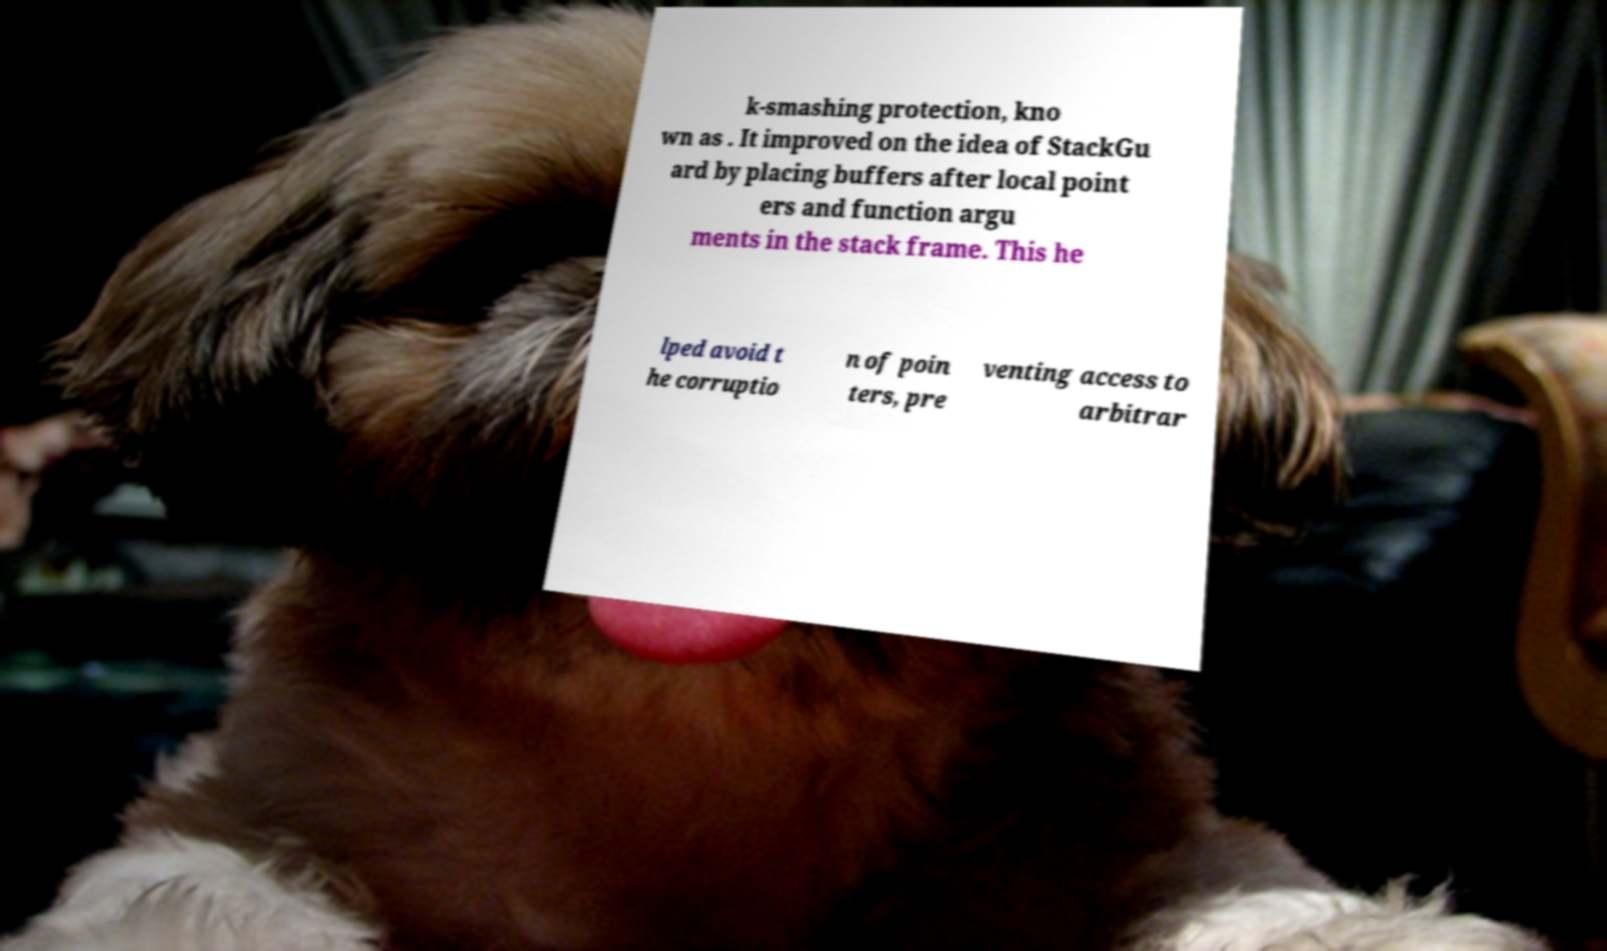There's text embedded in this image that I need extracted. Can you transcribe it verbatim? k-smashing protection, kno wn as . It improved on the idea of StackGu ard by placing buffers after local point ers and function argu ments in the stack frame. This he lped avoid t he corruptio n of poin ters, pre venting access to arbitrar 